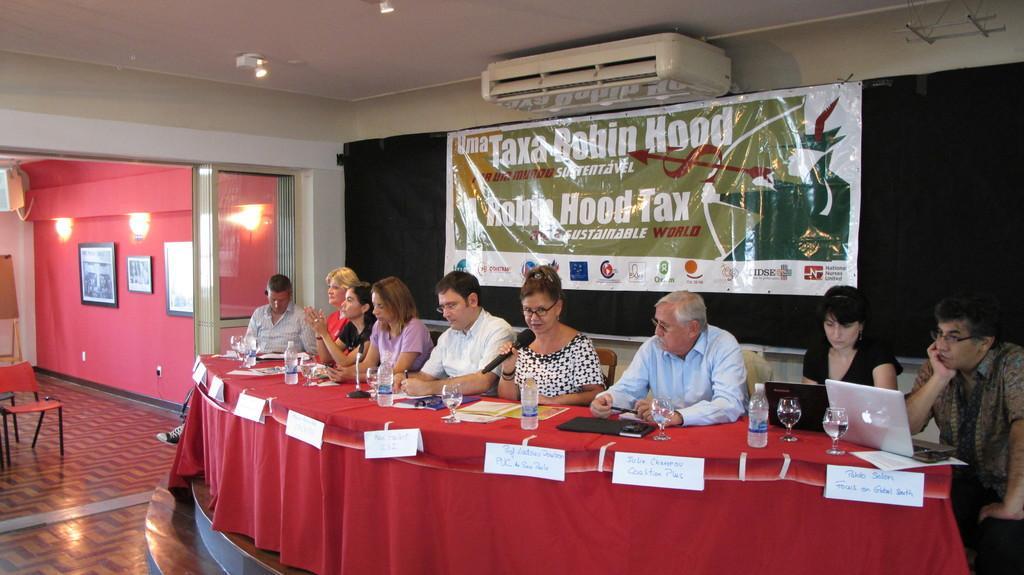Can you describe this image briefly? In this picture we can see group of people sitting on chair and in front of them we have table and on table we can see bottle, glass, laptops some stickers to it and here in front woman holding mic and talking and in the background we can see banner, wall, frames,light, chair. 